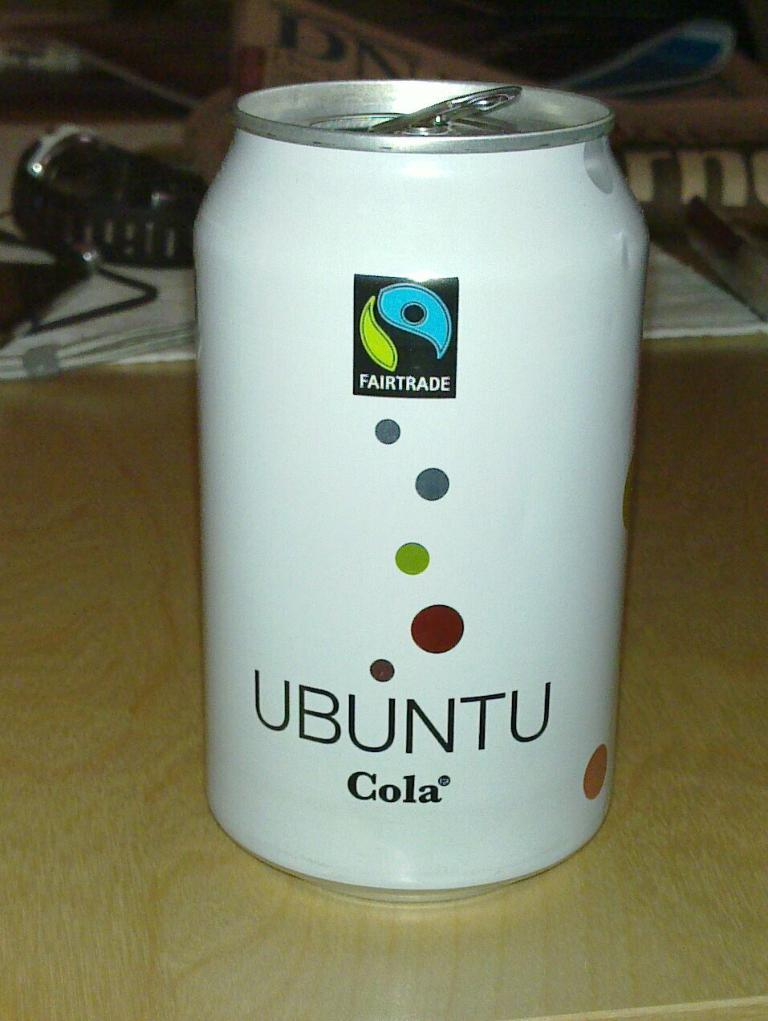Provide a one-sentence caption for the provided image. A white soda can says Ubuntu Cola and a wrist watch is behind it on the table. 